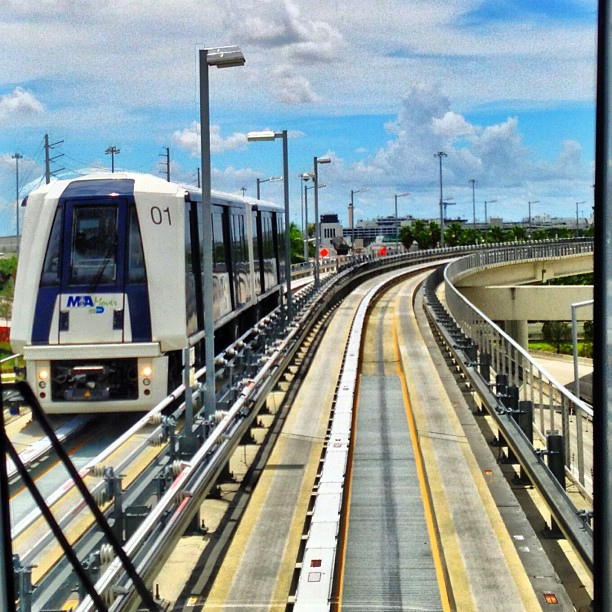Identify and read out the text in this image. 01 MA 